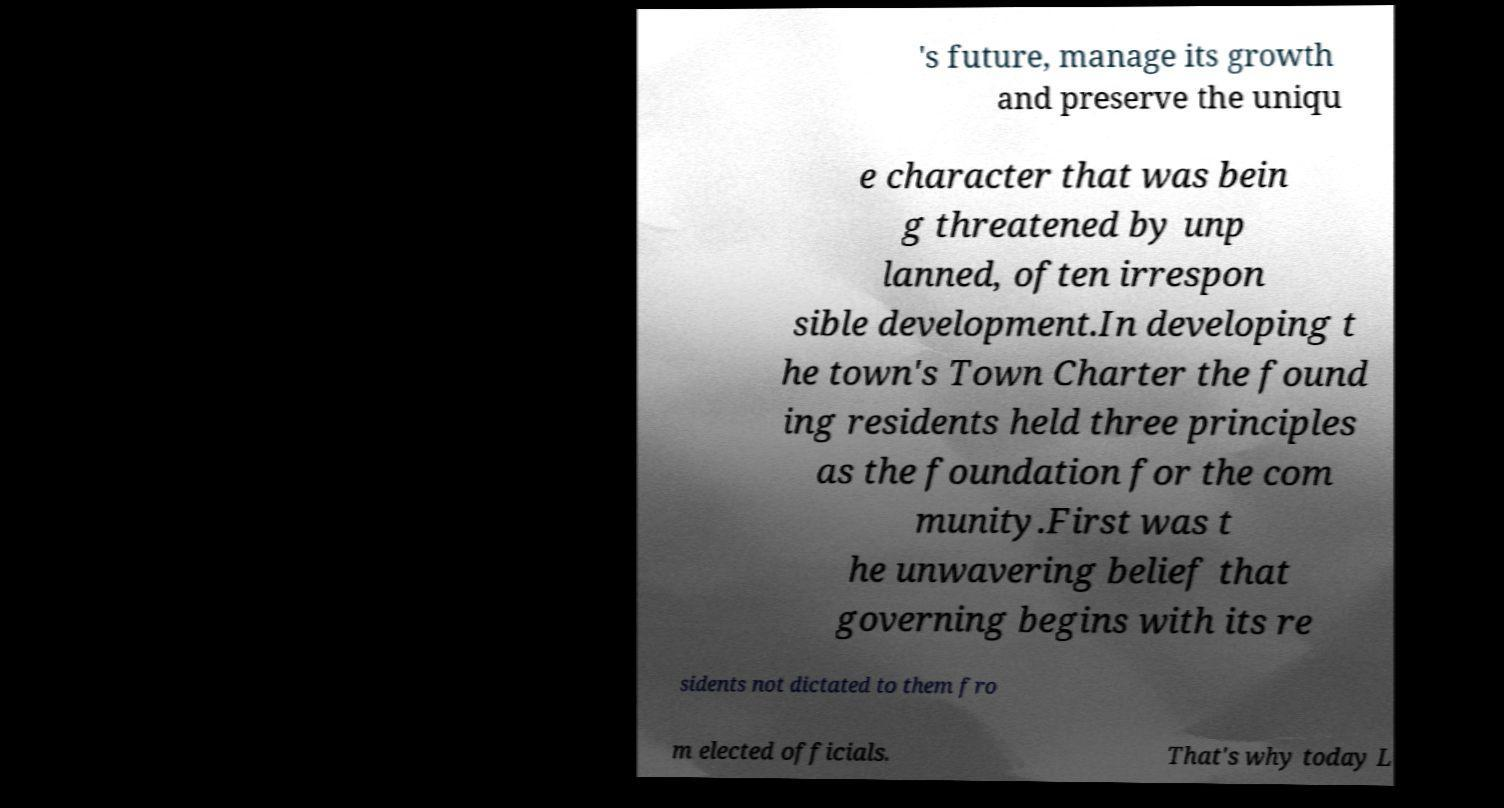Please read and relay the text visible in this image. What does it say? 's future, manage its growth and preserve the uniqu e character that was bein g threatened by unp lanned, often irrespon sible development.In developing t he town's Town Charter the found ing residents held three principles as the foundation for the com munity.First was t he unwavering belief that governing begins with its re sidents not dictated to them fro m elected officials. That's why today L 